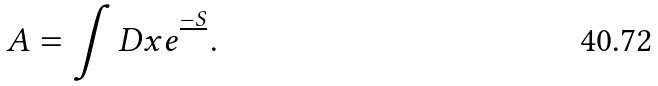Convert formula to latex. <formula><loc_0><loc_0><loc_500><loc_500>A = \int D x e ^ { \frac { - S } { } } .</formula> 